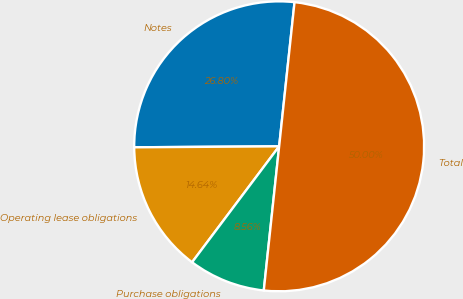Convert chart to OTSL. <chart><loc_0><loc_0><loc_500><loc_500><pie_chart><fcel>Notes<fcel>Operating lease obligations<fcel>Purchase obligations<fcel>Total<nl><fcel>26.8%<fcel>14.64%<fcel>8.56%<fcel>50.0%<nl></chart> 